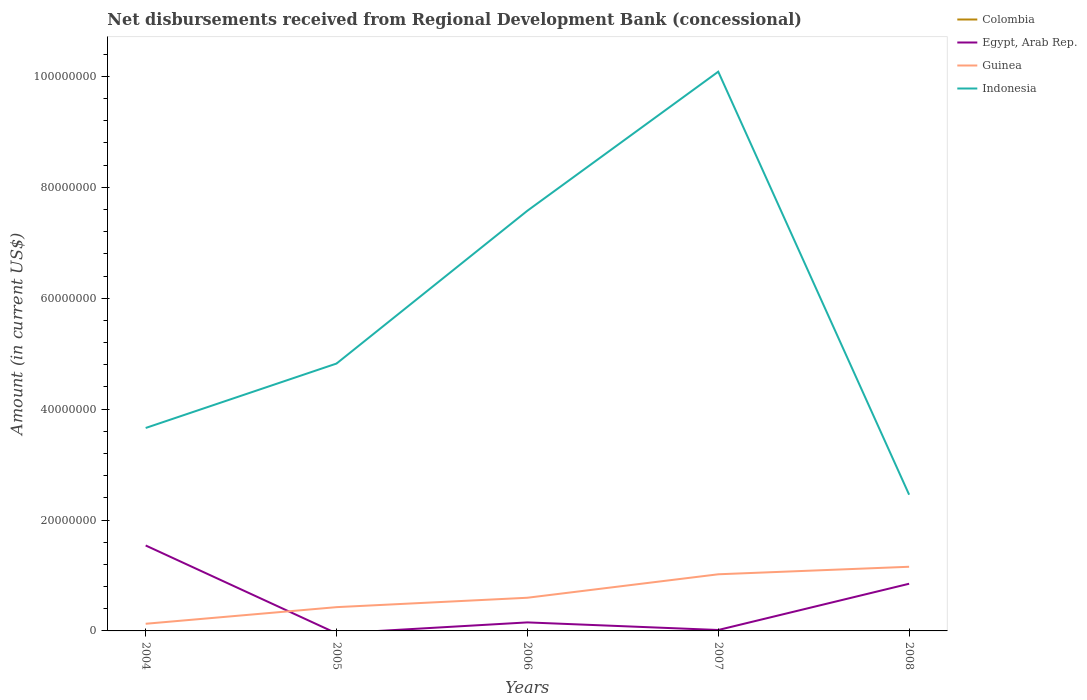How many different coloured lines are there?
Give a very brief answer. 3. Is the number of lines equal to the number of legend labels?
Your answer should be very brief. No. Across all years, what is the maximum amount of disbursements received from Regional Development Bank in Guinea?
Offer a terse response. 1.29e+06. What is the total amount of disbursements received from Regional Development Bank in Guinea in the graph?
Give a very brief answer. -1.36e+06. What is the difference between the highest and the second highest amount of disbursements received from Regional Development Bank in Indonesia?
Offer a very short reply. 7.63e+07. How many years are there in the graph?
Provide a succinct answer. 5. What is the difference between two consecutive major ticks on the Y-axis?
Give a very brief answer. 2.00e+07. Are the values on the major ticks of Y-axis written in scientific E-notation?
Your answer should be very brief. No. Does the graph contain any zero values?
Offer a very short reply. Yes. Does the graph contain grids?
Offer a terse response. No. Where does the legend appear in the graph?
Keep it short and to the point. Top right. How many legend labels are there?
Make the answer very short. 4. What is the title of the graph?
Provide a succinct answer. Net disbursements received from Regional Development Bank (concessional). What is the Amount (in current US$) of Colombia in 2004?
Your answer should be very brief. 0. What is the Amount (in current US$) in Egypt, Arab Rep. in 2004?
Offer a terse response. 1.54e+07. What is the Amount (in current US$) of Guinea in 2004?
Keep it short and to the point. 1.29e+06. What is the Amount (in current US$) in Indonesia in 2004?
Your answer should be very brief. 3.66e+07. What is the Amount (in current US$) in Colombia in 2005?
Your response must be concise. 0. What is the Amount (in current US$) of Guinea in 2005?
Your answer should be very brief. 4.29e+06. What is the Amount (in current US$) of Indonesia in 2005?
Offer a terse response. 4.82e+07. What is the Amount (in current US$) in Colombia in 2006?
Offer a very short reply. 0. What is the Amount (in current US$) in Egypt, Arab Rep. in 2006?
Make the answer very short. 1.54e+06. What is the Amount (in current US$) in Guinea in 2006?
Offer a very short reply. 5.98e+06. What is the Amount (in current US$) in Indonesia in 2006?
Give a very brief answer. 7.58e+07. What is the Amount (in current US$) of Egypt, Arab Rep. in 2007?
Provide a short and direct response. 1.67e+05. What is the Amount (in current US$) of Guinea in 2007?
Give a very brief answer. 1.02e+07. What is the Amount (in current US$) in Indonesia in 2007?
Provide a succinct answer. 1.01e+08. What is the Amount (in current US$) in Egypt, Arab Rep. in 2008?
Provide a short and direct response. 8.51e+06. What is the Amount (in current US$) of Guinea in 2008?
Your answer should be compact. 1.16e+07. What is the Amount (in current US$) in Indonesia in 2008?
Provide a succinct answer. 2.46e+07. Across all years, what is the maximum Amount (in current US$) of Egypt, Arab Rep.?
Give a very brief answer. 1.54e+07. Across all years, what is the maximum Amount (in current US$) in Guinea?
Provide a succinct answer. 1.16e+07. Across all years, what is the maximum Amount (in current US$) in Indonesia?
Your response must be concise. 1.01e+08. Across all years, what is the minimum Amount (in current US$) of Guinea?
Offer a very short reply. 1.29e+06. Across all years, what is the minimum Amount (in current US$) in Indonesia?
Offer a very short reply. 2.46e+07. What is the total Amount (in current US$) in Egypt, Arab Rep. in the graph?
Make the answer very short. 2.56e+07. What is the total Amount (in current US$) in Guinea in the graph?
Provide a succinct answer. 3.33e+07. What is the total Amount (in current US$) in Indonesia in the graph?
Make the answer very short. 2.86e+08. What is the difference between the Amount (in current US$) in Guinea in 2004 and that in 2005?
Keep it short and to the point. -3.00e+06. What is the difference between the Amount (in current US$) in Indonesia in 2004 and that in 2005?
Provide a succinct answer. -1.16e+07. What is the difference between the Amount (in current US$) of Egypt, Arab Rep. in 2004 and that in 2006?
Give a very brief answer. 1.39e+07. What is the difference between the Amount (in current US$) in Guinea in 2004 and that in 2006?
Offer a terse response. -4.69e+06. What is the difference between the Amount (in current US$) in Indonesia in 2004 and that in 2006?
Ensure brevity in your answer.  -3.92e+07. What is the difference between the Amount (in current US$) of Egypt, Arab Rep. in 2004 and that in 2007?
Provide a succinct answer. 1.52e+07. What is the difference between the Amount (in current US$) of Guinea in 2004 and that in 2007?
Offer a terse response. -8.92e+06. What is the difference between the Amount (in current US$) in Indonesia in 2004 and that in 2007?
Ensure brevity in your answer.  -6.43e+07. What is the difference between the Amount (in current US$) of Egypt, Arab Rep. in 2004 and that in 2008?
Offer a terse response. 6.90e+06. What is the difference between the Amount (in current US$) in Guinea in 2004 and that in 2008?
Your response must be concise. -1.03e+07. What is the difference between the Amount (in current US$) of Indonesia in 2004 and that in 2008?
Provide a succinct answer. 1.20e+07. What is the difference between the Amount (in current US$) of Guinea in 2005 and that in 2006?
Offer a terse response. -1.70e+06. What is the difference between the Amount (in current US$) in Indonesia in 2005 and that in 2006?
Keep it short and to the point. -2.76e+07. What is the difference between the Amount (in current US$) in Guinea in 2005 and that in 2007?
Provide a short and direct response. -5.93e+06. What is the difference between the Amount (in current US$) in Indonesia in 2005 and that in 2007?
Provide a short and direct response. -5.26e+07. What is the difference between the Amount (in current US$) in Guinea in 2005 and that in 2008?
Make the answer very short. -7.28e+06. What is the difference between the Amount (in current US$) of Indonesia in 2005 and that in 2008?
Your response must be concise. 2.37e+07. What is the difference between the Amount (in current US$) of Egypt, Arab Rep. in 2006 and that in 2007?
Provide a succinct answer. 1.37e+06. What is the difference between the Amount (in current US$) in Guinea in 2006 and that in 2007?
Make the answer very short. -4.23e+06. What is the difference between the Amount (in current US$) of Indonesia in 2006 and that in 2007?
Provide a succinct answer. -2.51e+07. What is the difference between the Amount (in current US$) in Egypt, Arab Rep. in 2006 and that in 2008?
Provide a succinct answer. -6.97e+06. What is the difference between the Amount (in current US$) in Guinea in 2006 and that in 2008?
Ensure brevity in your answer.  -5.59e+06. What is the difference between the Amount (in current US$) in Indonesia in 2006 and that in 2008?
Your response must be concise. 5.12e+07. What is the difference between the Amount (in current US$) in Egypt, Arab Rep. in 2007 and that in 2008?
Ensure brevity in your answer.  -8.34e+06. What is the difference between the Amount (in current US$) of Guinea in 2007 and that in 2008?
Offer a very short reply. -1.36e+06. What is the difference between the Amount (in current US$) in Indonesia in 2007 and that in 2008?
Your answer should be very brief. 7.63e+07. What is the difference between the Amount (in current US$) of Egypt, Arab Rep. in 2004 and the Amount (in current US$) of Guinea in 2005?
Your answer should be compact. 1.11e+07. What is the difference between the Amount (in current US$) in Egypt, Arab Rep. in 2004 and the Amount (in current US$) in Indonesia in 2005?
Offer a very short reply. -3.28e+07. What is the difference between the Amount (in current US$) in Guinea in 2004 and the Amount (in current US$) in Indonesia in 2005?
Offer a very short reply. -4.69e+07. What is the difference between the Amount (in current US$) of Egypt, Arab Rep. in 2004 and the Amount (in current US$) of Guinea in 2006?
Your answer should be very brief. 9.43e+06. What is the difference between the Amount (in current US$) in Egypt, Arab Rep. in 2004 and the Amount (in current US$) in Indonesia in 2006?
Your response must be concise. -6.04e+07. What is the difference between the Amount (in current US$) in Guinea in 2004 and the Amount (in current US$) in Indonesia in 2006?
Your answer should be compact. -7.45e+07. What is the difference between the Amount (in current US$) in Egypt, Arab Rep. in 2004 and the Amount (in current US$) in Guinea in 2007?
Your answer should be compact. 5.20e+06. What is the difference between the Amount (in current US$) of Egypt, Arab Rep. in 2004 and the Amount (in current US$) of Indonesia in 2007?
Provide a short and direct response. -8.54e+07. What is the difference between the Amount (in current US$) of Guinea in 2004 and the Amount (in current US$) of Indonesia in 2007?
Your answer should be compact. -9.96e+07. What is the difference between the Amount (in current US$) of Egypt, Arab Rep. in 2004 and the Amount (in current US$) of Guinea in 2008?
Give a very brief answer. 3.84e+06. What is the difference between the Amount (in current US$) of Egypt, Arab Rep. in 2004 and the Amount (in current US$) of Indonesia in 2008?
Offer a terse response. -9.15e+06. What is the difference between the Amount (in current US$) in Guinea in 2004 and the Amount (in current US$) in Indonesia in 2008?
Your answer should be compact. -2.33e+07. What is the difference between the Amount (in current US$) in Guinea in 2005 and the Amount (in current US$) in Indonesia in 2006?
Offer a terse response. -7.15e+07. What is the difference between the Amount (in current US$) in Guinea in 2005 and the Amount (in current US$) in Indonesia in 2007?
Offer a terse response. -9.66e+07. What is the difference between the Amount (in current US$) of Guinea in 2005 and the Amount (in current US$) of Indonesia in 2008?
Your answer should be compact. -2.03e+07. What is the difference between the Amount (in current US$) of Egypt, Arab Rep. in 2006 and the Amount (in current US$) of Guinea in 2007?
Offer a very short reply. -8.68e+06. What is the difference between the Amount (in current US$) in Egypt, Arab Rep. in 2006 and the Amount (in current US$) in Indonesia in 2007?
Keep it short and to the point. -9.93e+07. What is the difference between the Amount (in current US$) in Guinea in 2006 and the Amount (in current US$) in Indonesia in 2007?
Your answer should be very brief. -9.49e+07. What is the difference between the Amount (in current US$) of Egypt, Arab Rep. in 2006 and the Amount (in current US$) of Guinea in 2008?
Your answer should be very brief. -1.00e+07. What is the difference between the Amount (in current US$) of Egypt, Arab Rep. in 2006 and the Amount (in current US$) of Indonesia in 2008?
Offer a terse response. -2.30e+07. What is the difference between the Amount (in current US$) in Guinea in 2006 and the Amount (in current US$) in Indonesia in 2008?
Your answer should be very brief. -1.86e+07. What is the difference between the Amount (in current US$) in Egypt, Arab Rep. in 2007 and the Amount (in current US$) in Guinea in 2008?
Keep it short and to the point. -1.14e+07. What is the difference between the Amount (in current US$) in Egypt, Arab Rep. in 2007 and the Amount (in current US$) in Indonesia in 2008?
Make the answer very short. -2.44e+07. What is the difference between the Amount (in current US$) in Guinea in 2007 and the Amount (in current US$) in Indonesia in 2008?
Your response must be concise. -1.44e+07. What is the average Amount (in current US$) in Colombia per year?
Your response must be concise. 0. What is the average Amount (in current US$) in Egypt, Arab Rep. per year?
Your answer should be compact. 5.12e+06. What is the average Amount (in current US$) in Guinea per year?
Offer a terse response. 6.67e+06. What is the average Amount (in current US$) in Indonesia per year?
Offer a very short reply. 5.72e+07. In the year 2004, what is the difference between the Amount (in current US$) of Egypt, Arab Rep. and Amount (in current US$) of Guinea?
Provide a succinct answer. 1.41e+07. In the year 2004, what is the difference between the Amount (in current US$) of Egypt, Arab Rep. and Amount (in current US$) of Indonesia?
Your response must be concise. -2.12e+07. In the year 2004, what is the difference between the Amount (in current US$) of Guinea and Amount (in current US$) of Indonesia?
Offer a very short reply. -3.53e+07. In the year 2005, what is the difference between the Amount (in current US$) in Guinea and Amount (in current US$) in Indonesia?
Give a very brief answer. -4.39e+07. In the year 2006, what is the difference between the Amount (in current US$) of Egypt, Arab Rep. and Amount (in current US$) of Guinea?
Keep it short and to the point. -4.45e+06. In the year 2006, what is the difference between the Amount (in current US$) of Egypt, Arab Rep. and Amount (in current US$) of Indonesia?
Offer a very short reply. -7.42e+07. In the year 2006, what is the difference between the Amount (in current US$) of Guinea and Amount (in current US$) of Indonesia?
Offer a very short reply. -6.98e+07. In the year 2007, what is the difference between the Amount (in current US$) in Egypt, Arab Rep. and Amount (in current US$) in Guinea?
Offer a very short reply. -1.00e+07. In the year 2007, what is the difference between the Amount (in current US$) of Egypt, Arab Rep. and Amount (in current US$) of Indonesia?
Keep it short and to the point. -1.01e+08. In the year 2007, what is the difference between the Amount (in current US$) of Guinea and Amount (in current US$) of Indonesia?
Offer a very short reply. -9.06e+07. In the year 2008, what is the difference between the Amount (in current US$) of Egypt, Arab Rep. and Amount (in current US$) of Guinea?
Offer a very short reply. -3.06e+06. In the year 2008, what is the difference between the Amount (in current US$) in Egypt, Arab Rep. and Amount (in current US$) in Indonesia?
Provide a short and direct response. -1.61e+07. In the year 2008, what is the difference between the Amount (in current US$) in Guinea and Amount (in current US$) in Indonesia?
Offer a very short reply. -1.30e+07. What is the ratio of the Amount (in current US$) of Guinea in 2004 to that in 2005?
Make the answer very short. 0.3. What is the ratio of the Amount (in current US$) of Indonesia in 2004 to that in 2005?
Offer a terse response. 0.76. What is the ratio of the Amount (in current US$) of Egypt, Arab Rep. in 2004 to that in 2006?
Offer a very short reply. 10.03. What is the ratio of the Amount (in current US$) in Guinea in 2004 to that in 2006?
Offer a very short reply. 0.22. What is the ratio of the Amount (in current US$) in Indonesia in 2004 to that in 2006?
Give a very brief answer. 0.48. What is the ratio of the Amount (in current US$) of Egypt, Arab Rep. in 2004 to that in 2007?
Make the answer very short. 92.28. What is the ratio of the Amount (in current US$) of Guinea in 2004 to that in 2007?
Your response must be concise. 0.13. What is the ratio of the Amount (in current US$) in Indonesia in 2004 to that in 2007?
Provide a succinct answer. 0.36. What is the ratio of the Amount (in current US$) of Egypt, Arab Rep. in 2004 to that in 2008?
Provide a short and direct response. 1.81. What is the ratio of the Amount (in current US$) of Guinea in 2004 to that in 2008?
Keep it short and to the point. 0.11. What is the ratio of the Amount (in current US$) in Indonesia in 2004 to that in 2008?
Keep it short and to the point. 1.49. What is the ratio of the Amount (in current US$) in Guinea in 2005 to that in 2006?
Give a very brief answer. 0.72. What is the ratio of the Amount (in current US$) in Indonesia in 2005 to that in 2006?
Offer a very short reply. 0.64. What is the ratio of the Amount (in current US$) of Guinea in 2005 to that in 2007?
Your answer should be compact. 0.42. What is the ratio of the Amount (in current US$) in Indonesia in 2005 to that in 2007?
Offer a very short reply. 0.48. What is the ratio of the Amount (in current US$) in Guinea in 2005 to that in 2008?
Keep it short and to the point. 0.37. What is the ratio of the Amount (in current US$) in Indonesia in 2005 to that in 2008?
Your answer should be compact. 1.96. What is the ratio of the Amount (in current US$) of Egypt, Arab Rep. in 2006 to that in 2007?
Make the answer very short. 9.2. What is the ratio of the Amount (in current US$) in Guinea in 2006 to that in 2007?
Your answer should be very brief. 0.59. What is the ratio of the Amount (in current US$) of Indonesia in 2006 to that in 2007?
Make the answer very short. 0.75. What is the ratio of the Amount (in current US$) of Egypt, Arab Rep. in 2006 to that in 2008?
Give a very brief answer. 0.18. What is the ratio of the Amount (in current US$) in Guinea in 2006 to that in 2008?
Give a very brief answer. 0.52. What is the ratio of the Amount (in current US$) of Indonesia in 2006 to that in 2008?
Your response must be concise. 3.09. What is the ratio of the Amount (in current US$) of Egypt, Arab Rep. in 2007 to that in 2008?
Offer a terse response. 0.02. What is the ratio of the Amount (in current US$) of Guinea in 2007 to that in 2008?
Your answer should be compact. 0.88. What is the ratio of the Amount (in current US$) of Indonesia in 2007 to that in 2008?
Provide a short and direct response. 4.11. What is the difference between the highest and the second highest Amount (in current US$) in Egypt, Arab Rep.?
Your response must be concise. 6.90e+06. What is the difference between the highest and the second highest Amount (in current US$) in Guinea?
Give a very brief answer. 1.36e+06. What is the difference between the highest and the second highest Amount (in current US$) of Indonesia?
Provide a short and direct response. 2.51e+07. What is the difference between the highest and the lowest Amount (in current US$) of Egypt, Arab Rep.?
Give a very brief answer. 1.54e+07. What is the difference between the highest and the lowest Amount (in current US$) of Guinea?
Offer a terse response. 1.03e+07. What is the difference between the highest and the lowest Amount (in current US$) in Indonesia?
Ensure brevity in your answer.  7.63e+07. 